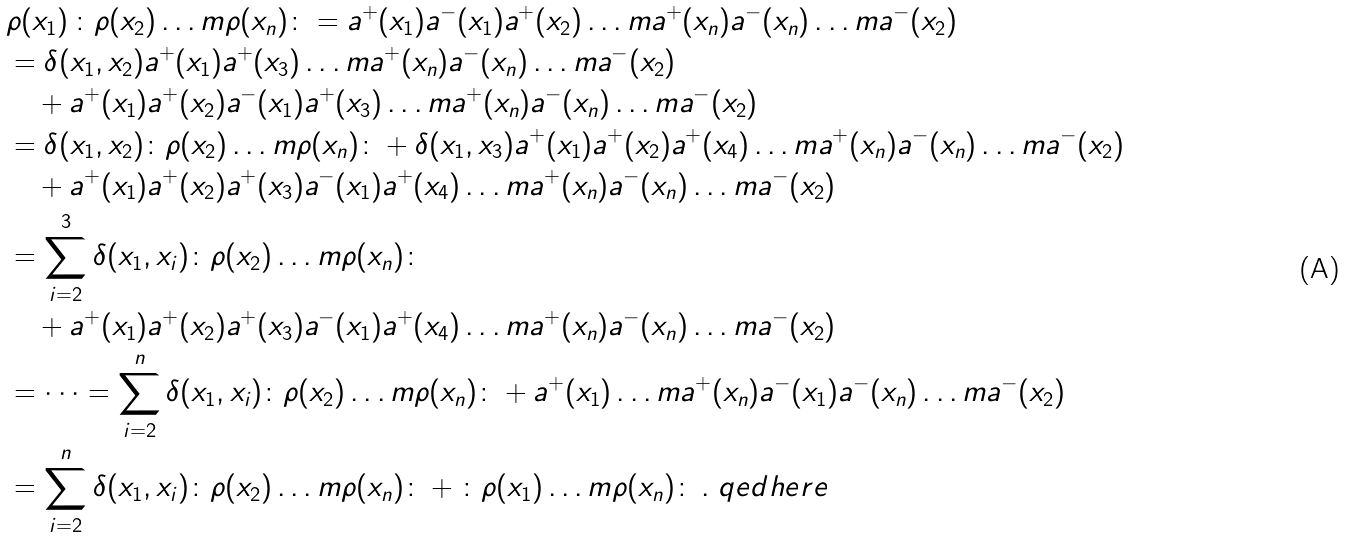Convert formula to latex. <formula><loc_0><loc_0><loc_500><loc_500>& \rho ( x _ { 1 } ) \, { \colon } \rho ( x _ { 2 } ) \dots m \rho ( x _ { n } ) { \colon } = a ^ { + } ( x _ { 1 } ) a ^ { - } ( x _ { 1 } ) a ^ { + } ( x _ { 2 } ) \dots m a ^ { + } ( x _ { n } ) a ^ { - } ( x _ { n } ) \dots m a ^ { - } ( x _ { 2 } ) \\ & = \delta ( x _ { 1 } , x _ { 2 } ) a ^ { + } ( x _ { 1 } ) a ^ { + } ( x _ { 3 } ) \dots m a ^ { + } ( x _ { n } ) a ^ { - } ( x _ { n } ) \dots m a ^ { - } ( x _ { 2 } ) \\ & \quad + a ^ { + } ( x _ { 1 } ) a ^ { + } ( x _ { 2 } ) a ^ { - } ( x _ { 1 } ) a ^ { + } ( x _ { 3 } ) \dots m a ^ { + } ( x _ { n } ) a ^ { - } ( x _ { n } ) \dots m a ^ { - } ( x _ { 2 } ) \\ & = \delta ( x _ { 1 } , x _ { 2 } ) { \colon } \rho ( x _ { 2 } ) \dots m \rho ( x _ { n } ) { \colon } + \delta ( x _ { 1 } , x _ { 3 } ) a ^ { + } ( x _ { 1 } ) a ^ { + } ( x _ { 2 } ) a ^ { + } ( x _ { 4 } ) \dots m a ^ { + } ( x _ { n } ) a ^ { - } ( x _ { n } ) \dots m a ^ { - } ( x _ { 2 } ) \\ & \quad + a ^ { + } ( x _ { 1 } ) a ^ { + } ( x _ { 2 } ) a ^ { + } ( x _ { 3 } ) a ^ { - } ( x _ { 1 } ) a ^ { + } ( x _ { 4 } ) \dots m a ^ { + } ( x _ { n } ) a ^ { - } ( x _ { n } ) \dots m a ^ { - } ( x _ { 2 } ) \\ & = \sum _ { i = 2 } ^ { 3 } \delta ( x _ { 1 } , x _ { i } ) { \colon } \rho ( x _ { 2 } ) \dots m \rho ( x _ { n } ) { \colon } \\ & \quad + a ^ { + } ( x _ { 1 } ) a ^ { + } ( x _ { 2 } ) a ^ { + } ( x _ { 3 } ) a ^ { - } ( x _ { 1 } ) a ^ { + } ( x _ { 4 } ) \dots m a ^ { + } ( x _ { n } ) a ^ { - } ( x _ { n } ) \dots m a ^ { - } ( x _ { 2 } ) \\ & = \dots = \sum _ { i = 2 } ^ { n } \delta ( x _ { 1 } , x _ { i } ) { \colon } \rho ( x _ { 2 } ) \dots m \rho ( x _ { n } ) { \colon } + a ^ { + } ( x _ { 1 } ) \dots m a ^ { + } ( x _ { n } ) a ^ { - } ( x _ { 1 } ) a ^ { - } ( x _ { n } ) \dots m a ^ { - } ( x _ { 2 } ) \\ & = \sum _ { i = 2 } ^ { n } \delta ( x _ { 1 } , x _ { i } ) { \colon } \rho ( x _ { 2 } ) \dots m \rho ( x _ { n } ) { \colon } + { \colon } \rho ( x _ { 1 } ) \dots m \rho ( x _ { n } ) { \colon } \, . \ q e d h e r e</formula> 